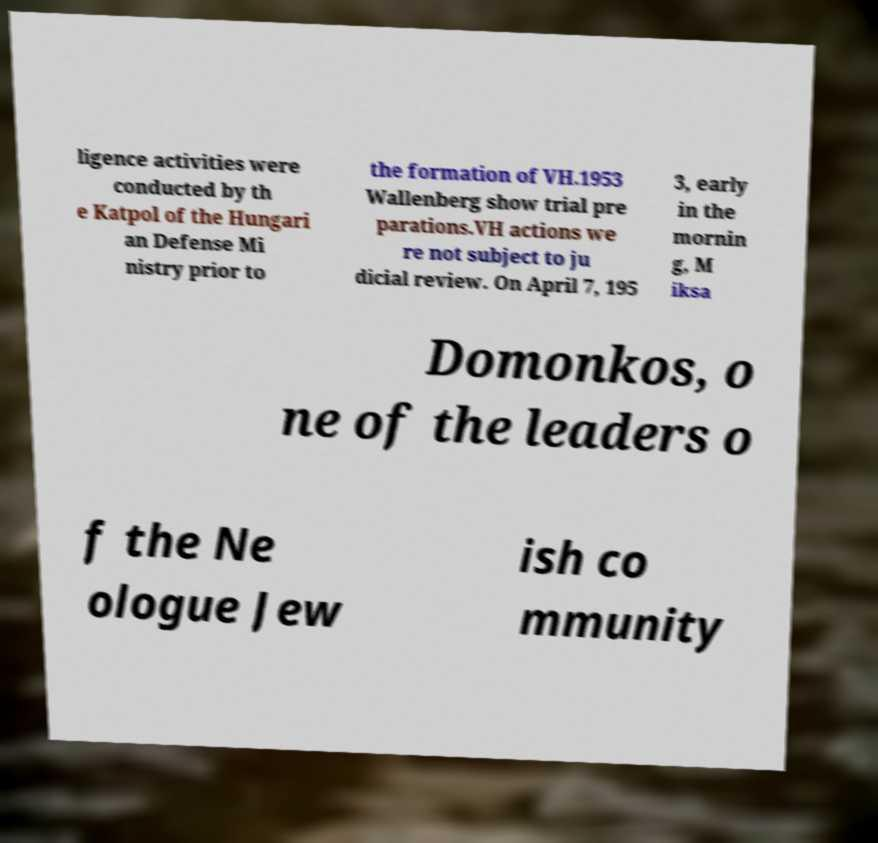Could you assist in decoding the text presented in this image and type it out clearly? ligence activities were conducted by th e Katpol of the Hungari an Defense Mi nistry prior to the formation of VH.1953 Wallenberg show trial pre parations.VH actions we re not subject to ju dicial review. On April 7, 195 3, early in the mornin g, M iksa Domonkos, o ne of the leaders o f the Ne ologue Jew ish co mmunity 